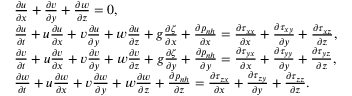Convert formula to latex. <formula><loc_0><loc_0><loc_500><loc_500>\begin{array} { r l } & { \frac { \partial u } { \partial x } + \frac { \partial v } { \partial y } + \frac { \partial w } { \partial z } = 0 , } \\ & { \frac { \partial u } { \partial t } + u \frac { \partial u } { \partial x } + v \frac { \partial u } { \partial y } + w \frac { \partial u } { \partial z } + g \frac { \partial \zeta } { \partial x } + \frac { \partial p _ { n h } } { \partial x } = \frac { \partial \tau _ { x x } } { \partial x } + \frac { \partial \tau _ { x y } } { \partial y } + \frac { \partial \tau _ { x z } } { \partial z } , } \\ & { \frac { \partial v } { \partial t } + u \frac { \partial v } { \partial x } + v \frac { \partial v } { \partial y } + w \frac { \partial v } { \partial z } + g \frac { \partial \zeta } { \partial y } + \frac { \partial p _ { n h } } { \partial y } = \frac { \partial \tau _ { y x } } { \partial x } + \frac { \partial \tau _ { y y } } { \partial y } + \frac { \partial \tau _ { y z } } { \partial z } , } \\ & { \frac { \partial w } { \partial t } + u \frac { \partial w } { \partial x } + v \frac { \partial w } { \partial y } + w \frac { \partial w } { \partial z } + \frac { \partial p _ { n h } } { \partial z } = \frac { \partial \tau _ { z x } } { \partial x } + \frac { \partial \tau _ { z y } } { \partial y } + \frac { \partial \tau _ { z z } } { \partial z } . } \end{array}</formula> 